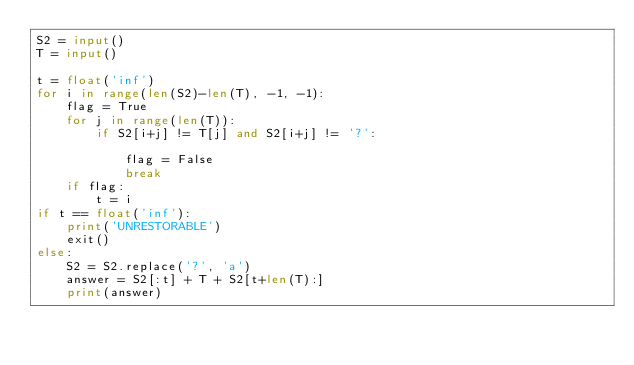<code> <loc_0><loc_0><loc_500><loc_500><_Python_>S2 = input()
T = input()

t = float('inf')
for i in range(len(S2)-len(T), -1, -1):
    flag = True
    for j in range(len(T)):
        if S2[i+j] != T[j] and S2[i+j] != '?':
            
            flag = False
            break
    if flag:
        t = i
if t == float('inf'):
    print('UNRESTORABLE')
    exit()
else:
    S2 = S2.replace('?', 'a')
    answer = S2[:t] + T + S2[t+len(T):]
    print(answer)
</code> 